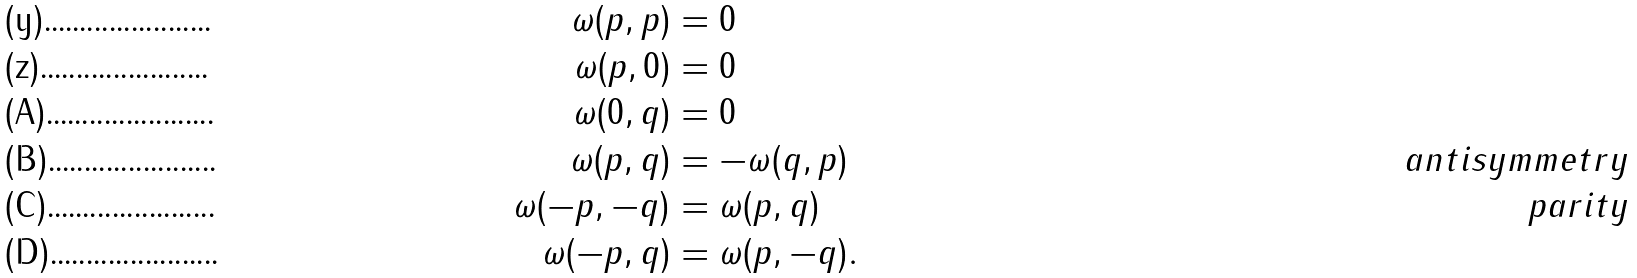<formula> <loc_0><loc_0><loc_500><loc_500>\omega ( p , p ) & = 0 \\ \omega ( p , 0 ) & = 0 \\ \omega ( 0 , q ) & = 0 \\ \omega ( p , q ) & = - \omega ( q , p ) & \quad a n t i s y m m e t r y \\ \omega ( - p , - q ) & = \omega ( p , q ) & \quad p a r i t y \\ \omega ( - p , q ) & = \omega ( p , - q ) .</formula> 